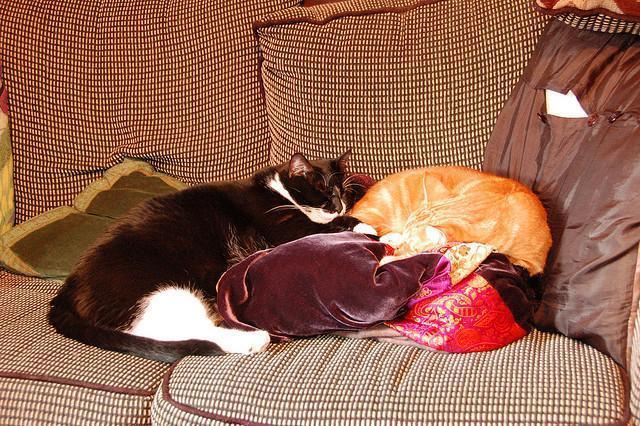How many blue train cars are there?
Give a very brief answer. 0. 